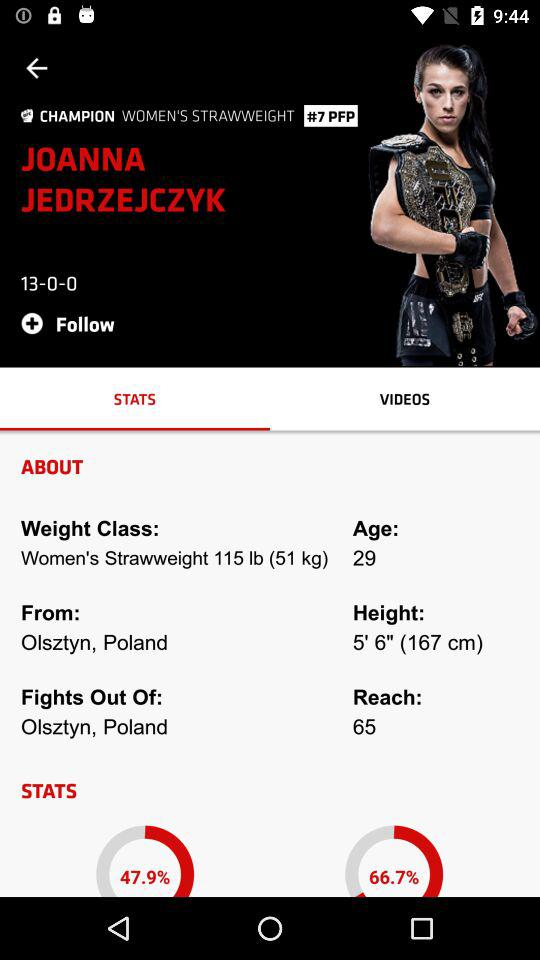What is the weight class of Joanna Jedrzejczyk? The weight class is "Women's Strawweight 115 lb (51 kg)". 